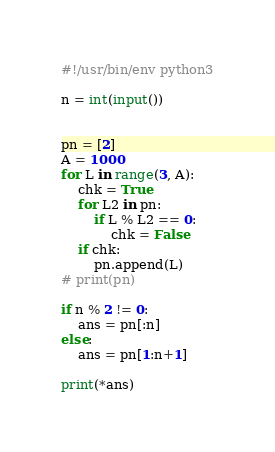<code> <loc_0><loc_0><loc_500><loc_500><_Python_>#!/usr/bin/env python3

n = int(input())


pn = [2]
A = 1000
for L in range(3, A):
    chk = True
    for L2 in pn:
        if L % L2 == 0:
            chk = False
    if chk:
        pn.append(L)
# print(pn)

if n % 2 != 0:
    ans = pn[:n]
else:
    ans = pn[1:n+1]

print(*ans)
</code> 